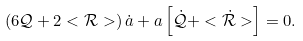Convert formula to latex. <formula><loc_0><loc_0><loc_500><loc_500>\left ( 6 \mathcal { Q } + 2 < \mathcal { R } > \right ) \dot { a } + a \left [ \dot { \mathcal { Q } } + < \dot { \mathcal { R } } > \right ] = 0 .</formula> 